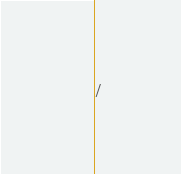<code> <loc_0><loc_0><loc_500><loc_500><_SQL_>/
</code> 